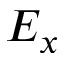Convert formula to latex. <formula><loc_0><loc_0><loc_500><loc_500>E _ { x }</formula> 